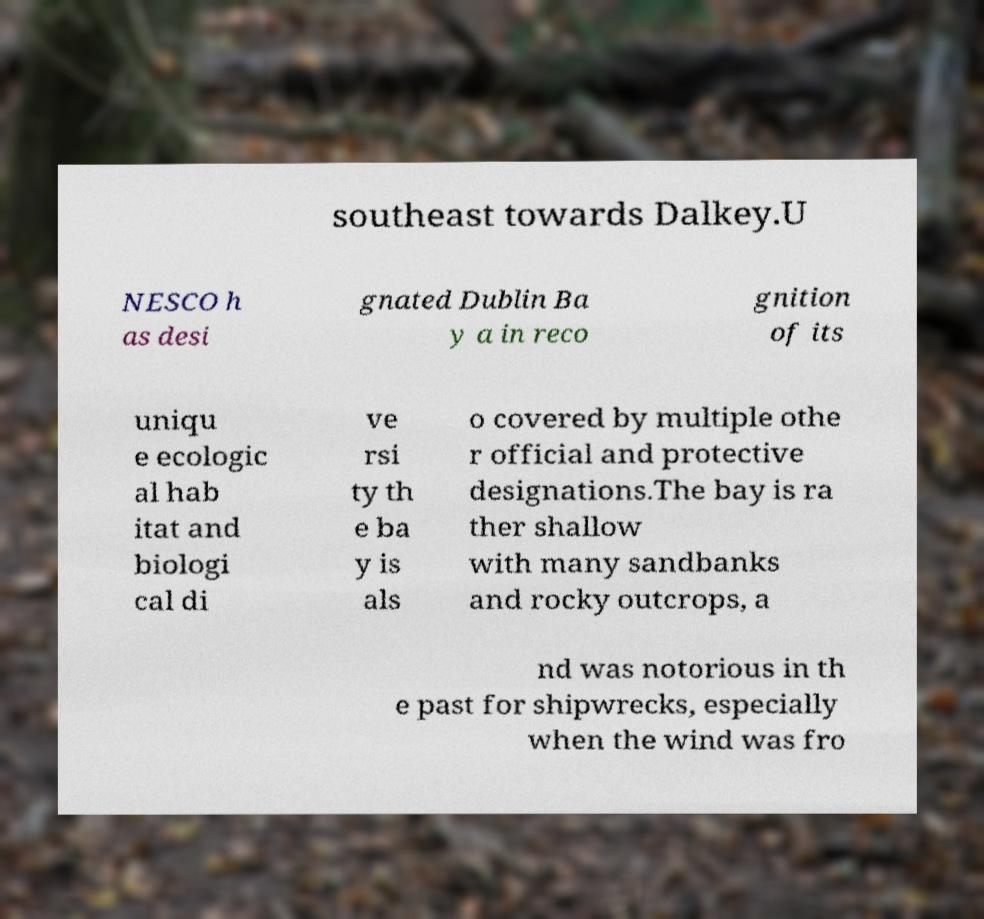Can you read and provide the text displayed in the image?This photo seems to have some interesting text. Can you extract and type it out for me? southeast towards Dalkey.U NESCO h as desi gnated Dublin Ba y a in reco gnition of its uniqu e ecologic al hab itat and biologi cal di ve rsi ty th e ba y is als o covered by multiple othe r official and protective designations.The bay is ra ther shallow with many sandbanks and rocky outcrops, a nd was notorious in th e past for shipwrecks, especially when the wind was fro 